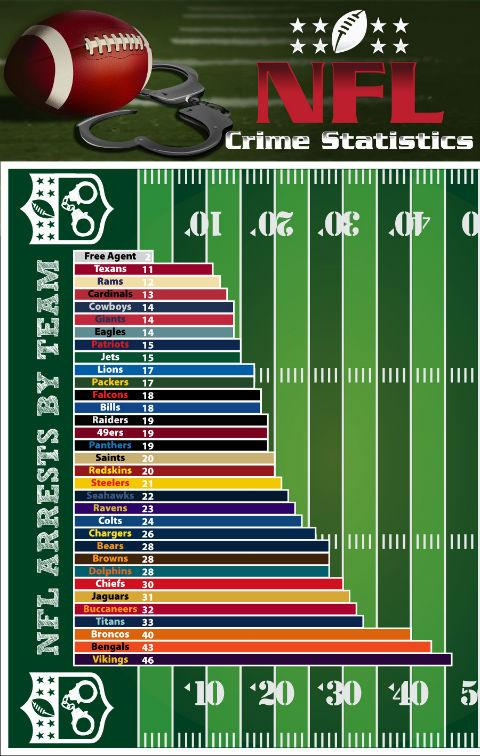Give some essential details in this illustration. Out of all the NFL teams, there are several that have had fewer than 10 arrests, making them ideal free agent targets. The NFL teams with more than 40 arrests are the Cincinnati Bengals and the Minnesota Vikings. It is reported that the NFL teams of the Cowboys, Giants, and Eagles have collectively recorded 14 arrests. 